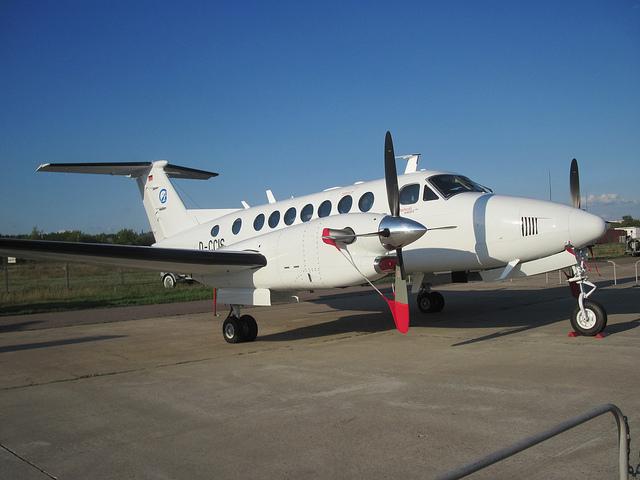Is this commercial flight?
Concise answer only. No. How many planes are in the picture?
Give a very brief answer. 1. How many people would be comfortably riding in this plane?
Quick response, please. 20. How many blades are on the propeller?
Short answer required. 4. How many tires are in this picture?
Keep it brief. 3. How many propellers are on the plane?
Answer briefly. 2. Is the weather clear for takeoff?
Answer briefly. Yes. Is it a cloudy day?
Answer briefly. No. What color are the stripes on the plane?
Be succinct. White. What is the weather like in the image?
Short answer required. Clear. How many engines on the plane?
Quick response, please. 2. What color is the airplane?
Quick response, please. White. What type of airplane is this?
Answer briefly. Propeller. Does this plane have a large capacity for many passengers?
Answer briefly. No. Are any of the wheels chocked?
Quick response, please. Yes. What is the climate like?
Give a very brief answer. Sunny. Is this a passenger plane?
Be succinct. Yes. 